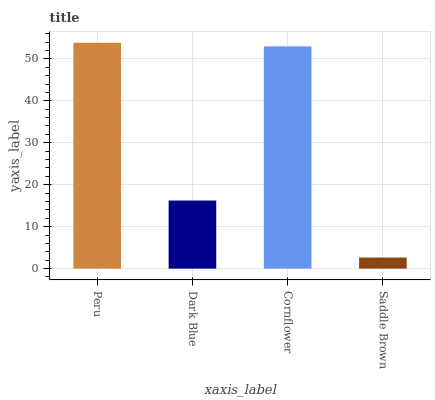Is Saddle Brown the minimum?
Answer yes or no. Yes. Is Peru the maximum?
Answer yes or no. Yes. Is Dark Blue the minimum?
Answer yes or no. No. Is Dark Blue the maximum?
Answer yes or no. No. Is Peru greater than Dark Blue?
Answer yes or no. Yes. Is Dark Blue less than Peru?
Answer yes or no. Yes. Is Dark Blue greater than Peru?
Answer yes or no. No. Is Peru less than Dark Blue?
Answer yes or no. No. Is Cornflower the high median?
Answer yes or no. Yes. Is Dark Blue the low median?
Answer yes or no. Yes. Is Dark Blue the high median?
Answer yes or no. No. Is Saddle Brown the low median?
Answer yes or no. No. 